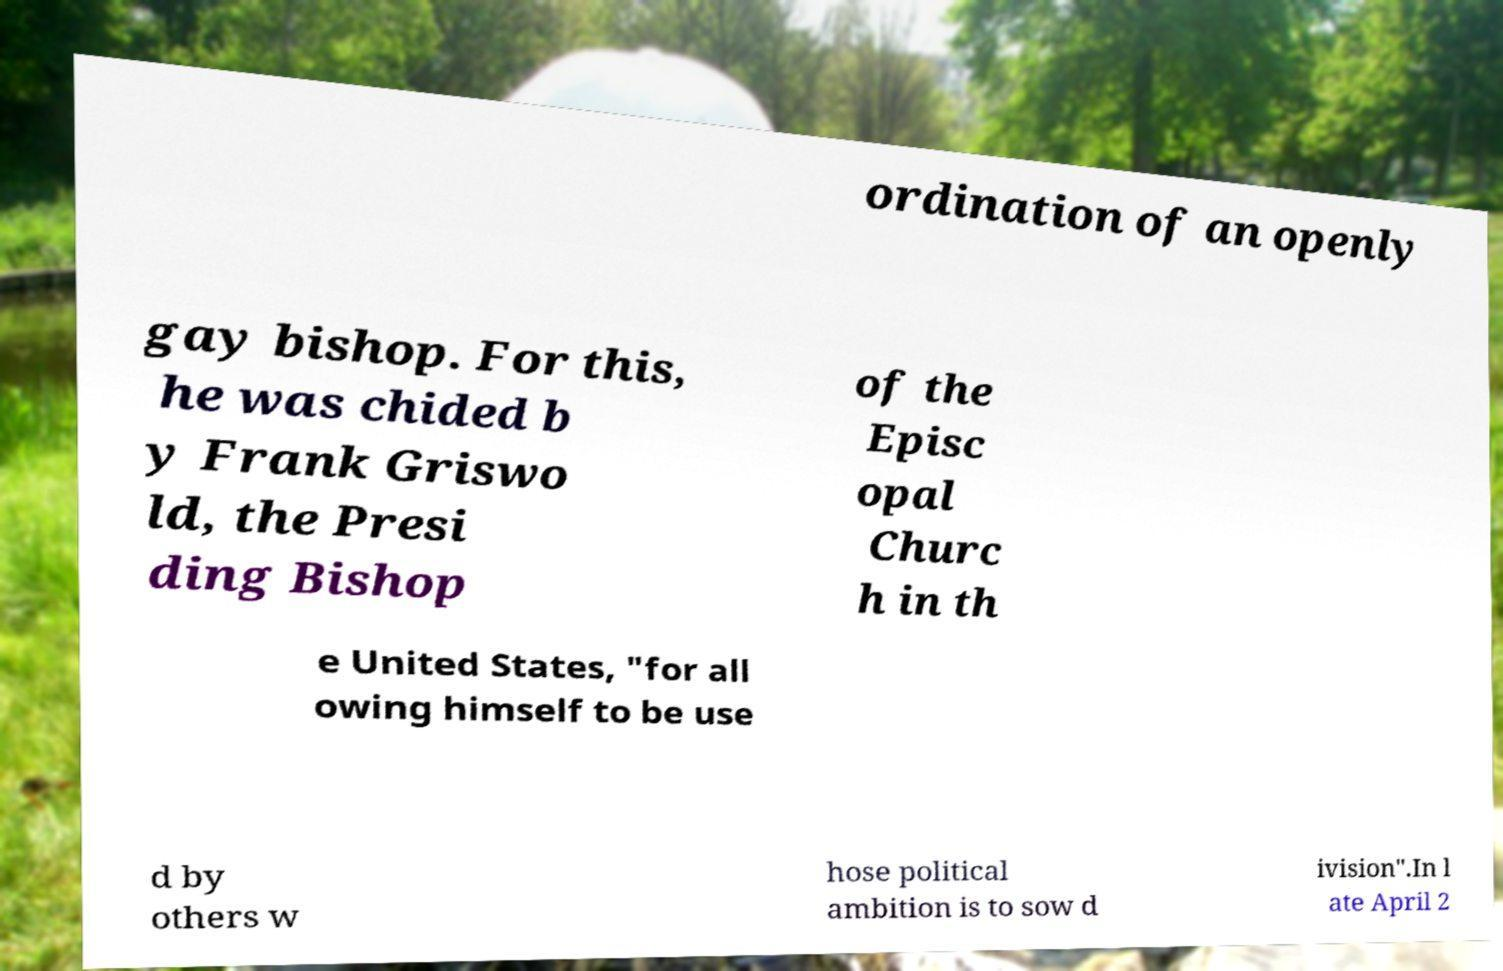What messages or text are displayed in this image? I need them in a readable, typed format. ordination of an openly gay bishop. For this, he was chided b y Frank Griswo ld, the Presi ding Bishop of the Episc opal Churc h in th e United States, "for all owing himself to be use d by others w hose political ambition is to sow d ivision".In l ate April 2 